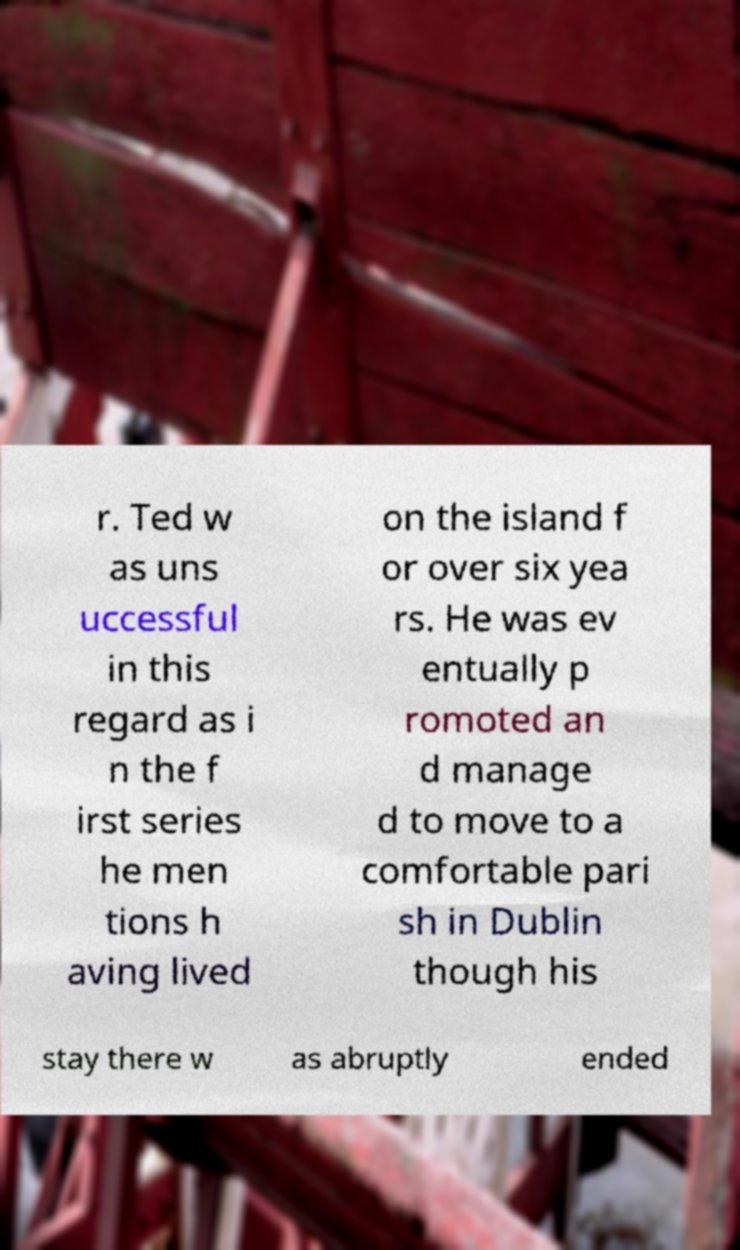Please identify and transcribe the text found in this image. r. Ted w as uns uccessful in this regard as i n the f irst series he men tions h aving lived on the island f or over six yea rs. He was ev entually p romoted an d manage d to move to a comfortable pari sh in Dublin though his stay there w as abruptly ended 